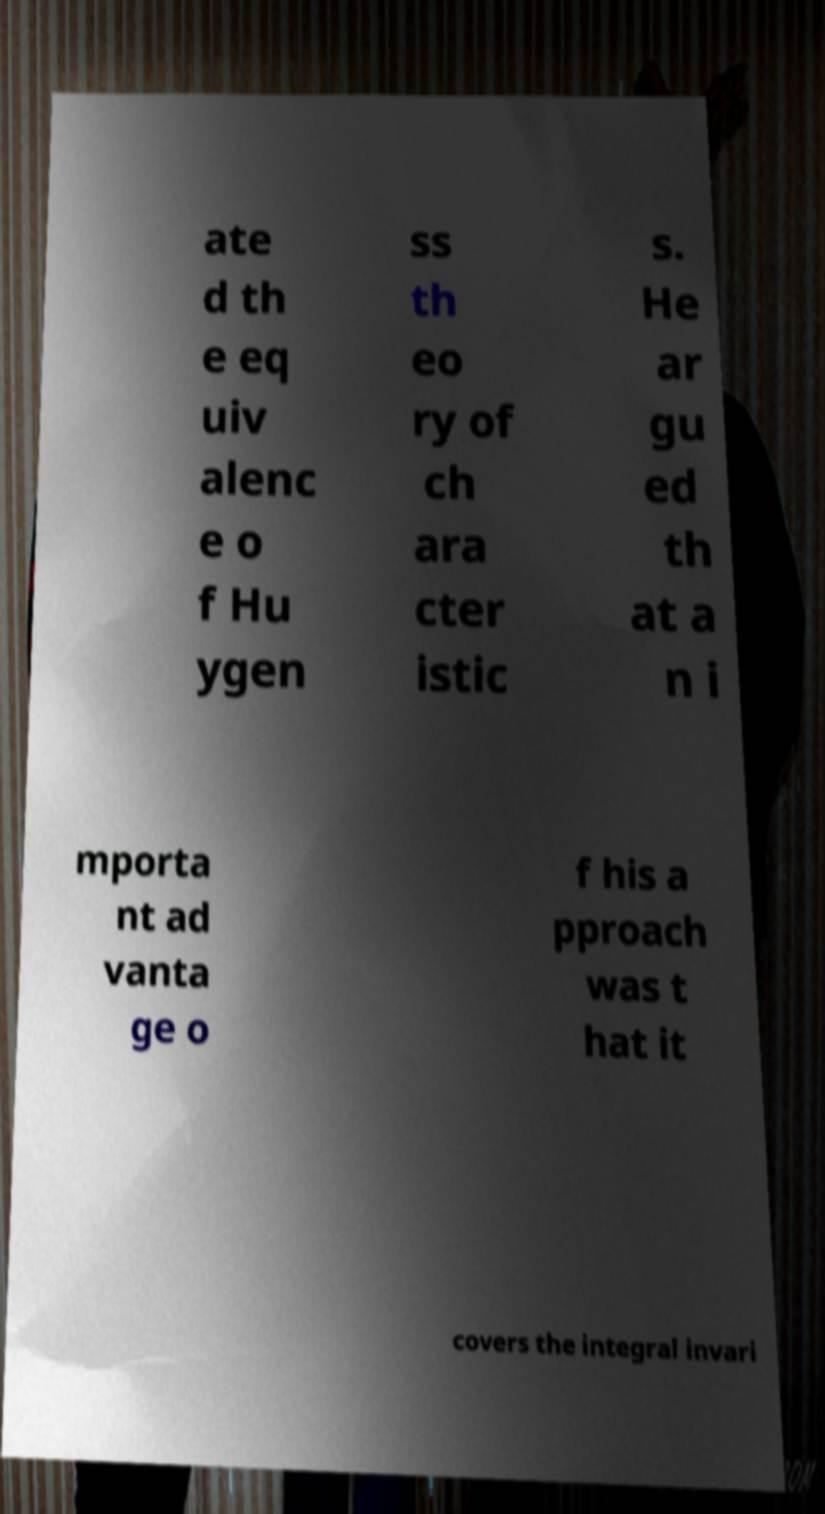There's text embedded in this image that I need extracted. Can you transcribe it verbatim? ate d th e eq uiv alenc e o f Hu ygen ss th eo ry of ch ara cter istic s. He ar gu ed th at a n i mporta nt ad vanta ge o f his a pproach was t hat it covers the integral invari 